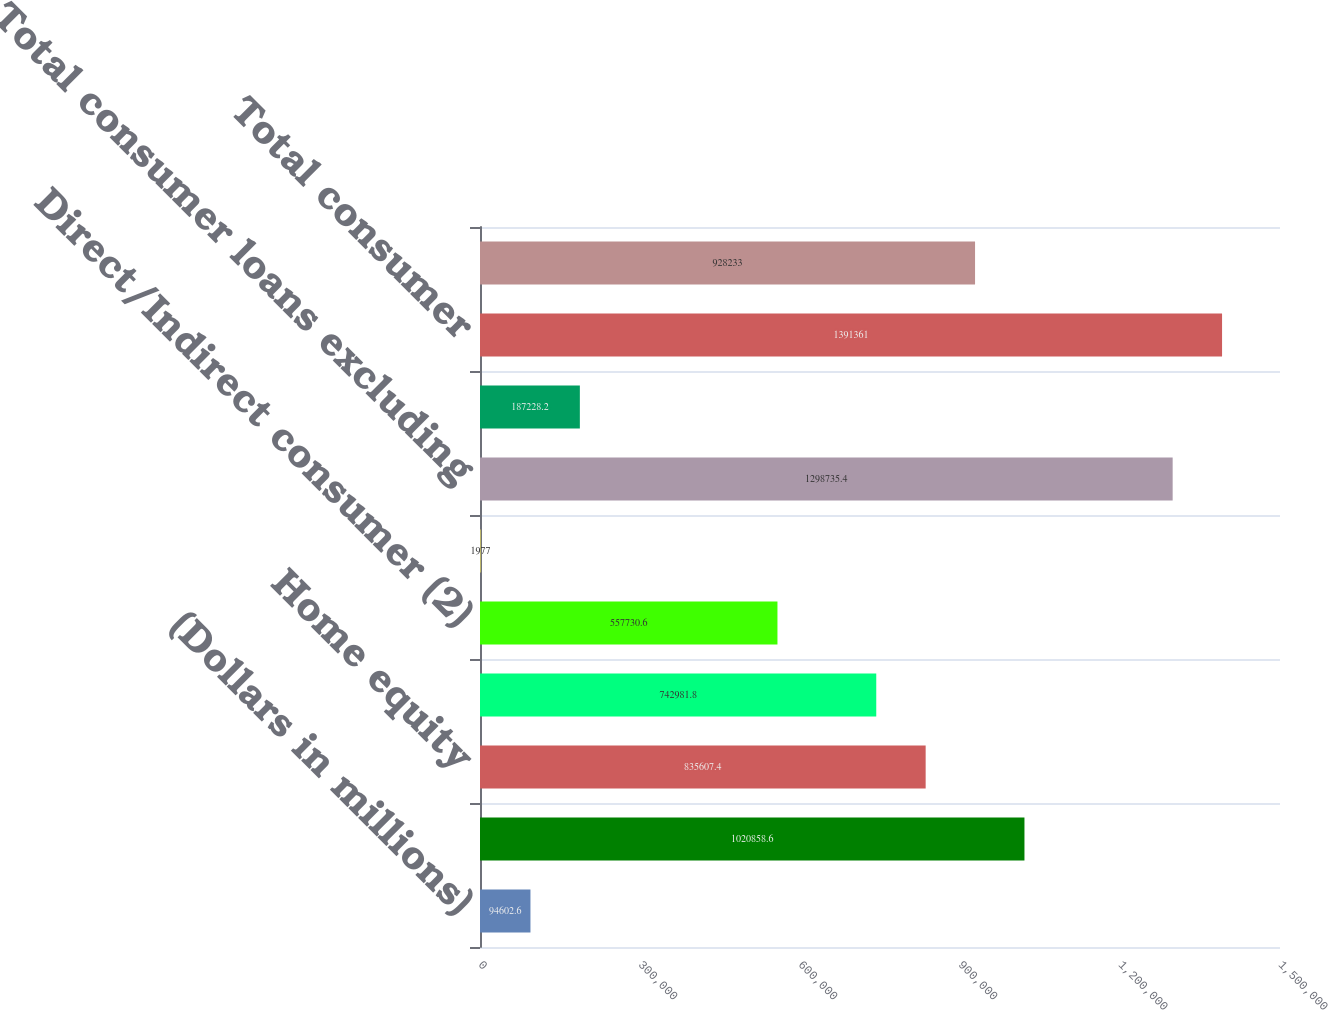<chart> <loc_0><loc_0><loc_500><loc_500><bar_chart><fcel>(Dollars in millions)<fcel>Residential mortgage (1)<fcel>Home equity<fcel>US credit card<fcel>Direct/Indirect consumer (2)<fcel>Other consumer (3)<fcel>Total consumer loans excluding<fcel>Consumer loans accounted for<fcel>Total consumer<fcel>US commercial (5)<nl><fcel>94602.6<fcel>1.02086e+06<fcel>835607<fcel>742982<fcel>557731<fcel>1977<fcel>1.29874e+06<fcel>187228<fcel>1.39136e+06<fcel>928233<nl></chart> 